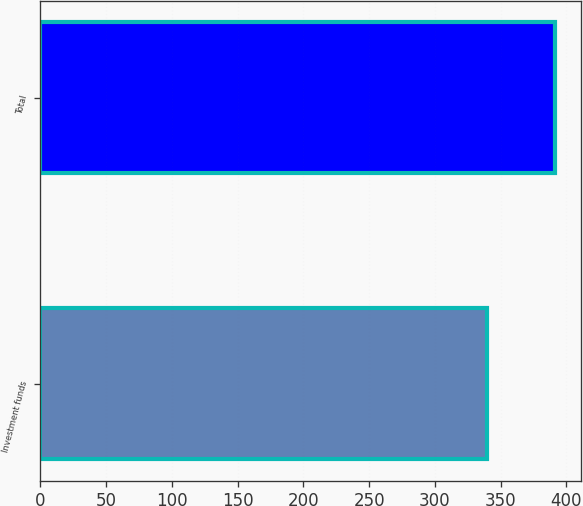Convert chart. <chart><loc_0><loc_0><loc_500><loc_500><bar_chart><fcel>Investment funds<fcel>Total<nl><fcel>339.9<fcel>391.3<nl></chart> 